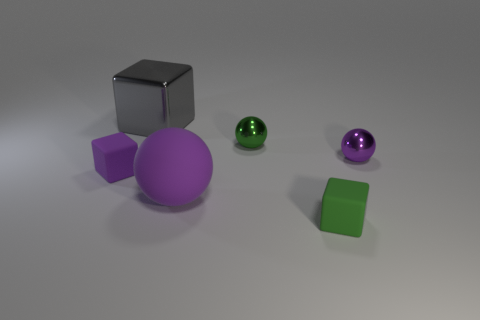Can you describe the shapes and colors of the objects in this image? Certainly! In the image, there are four objects, each with a distinct shape and color. Starting from the left, there's a silver cube, a purple sphere, a green smaller sphere, and finally a green cube. The lighting in the scene casts soft shadows and gives the objects a slight reflection on the surface they rest on. 